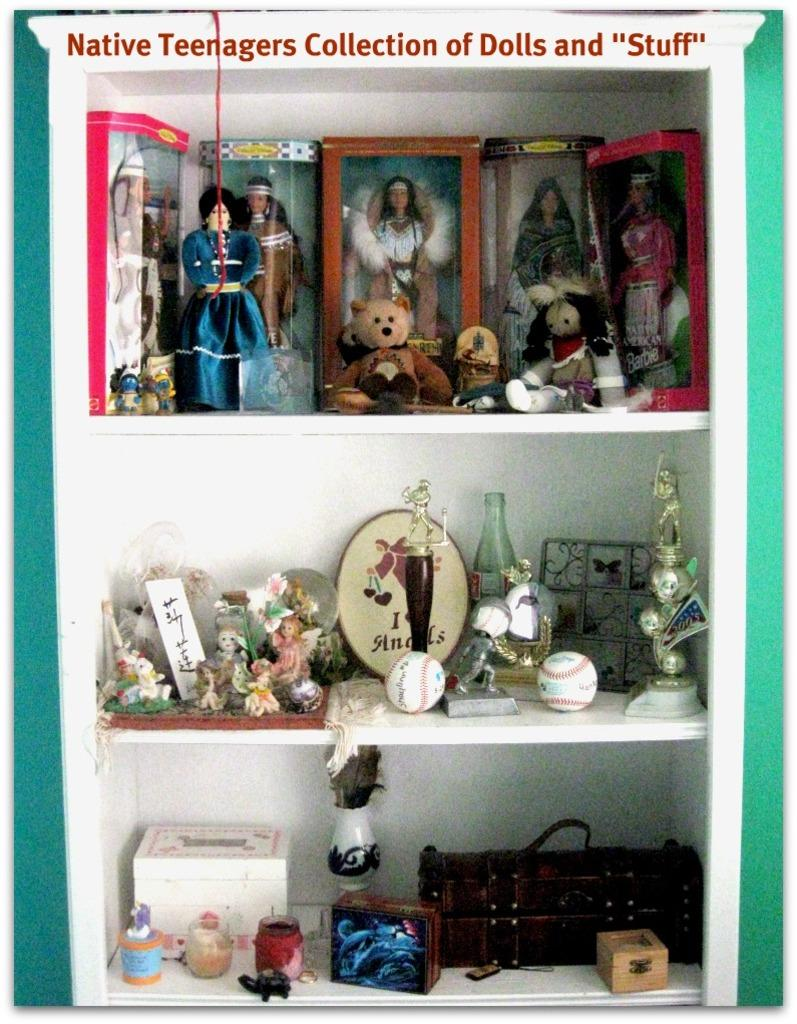What types of items can be seen in the image? There are toys, objects, show pieces, awards, and boxes in the image. How are the items arranged in the image? The items are arranged in shelves. Is there any text visible in the image? Yes, there is some text written at the top of the image. Can you tell me how many times the group turns around in the image? There is no group or turning action present in the image; it features various items arranged in shelves. What type of ornament is hanging from the top of the image? There is no ornament hanging from the top of the image; only text is visible. 